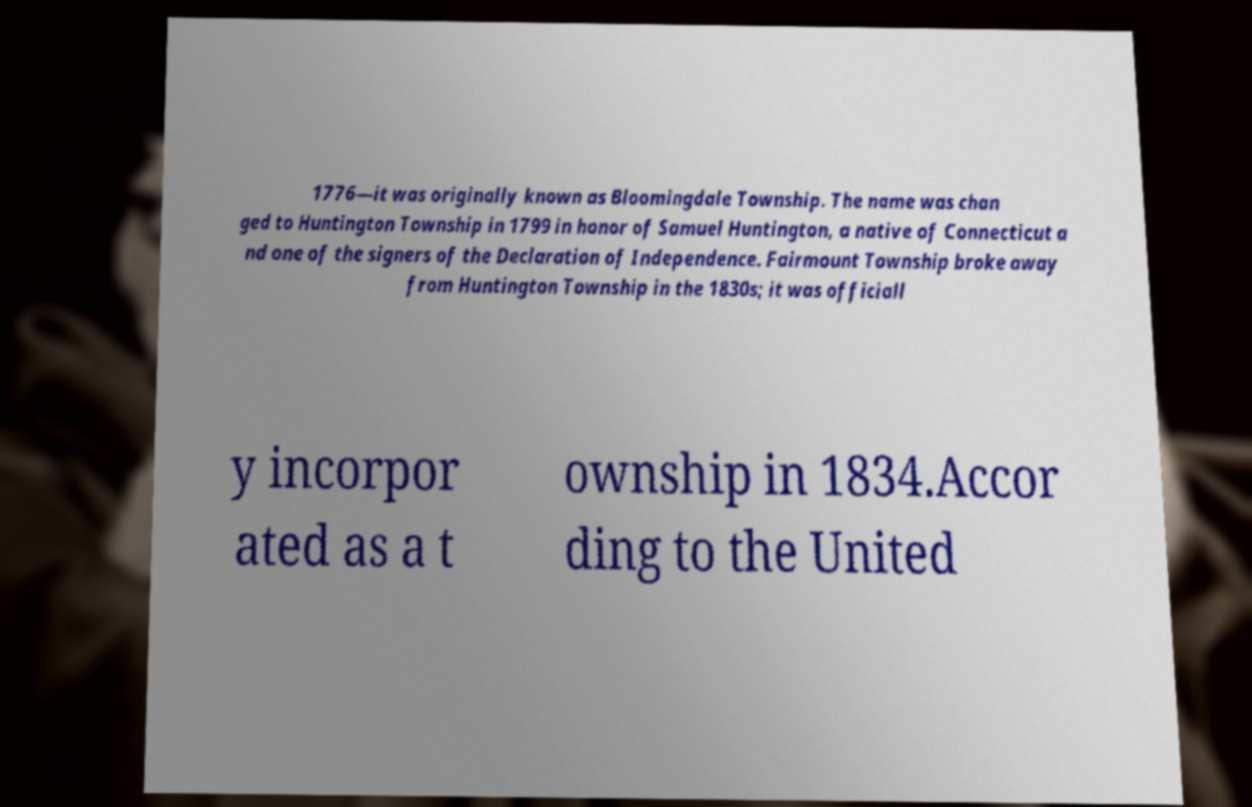What messages or text are displayed in this image? I need them in a readable, typed format. 1776—it was originally known as Bloomingdale Township. The name was chan ged to Huntington Township in 1799 in honor of Samuel Huntington, a native of Connecticut a nd one of the signers of the Declaration of Independence. Fairmount Township broke away from Huntington Township in the 1830s; it was officiall y incorpor ated as a t ownship in 1834.Accor ding to the United 